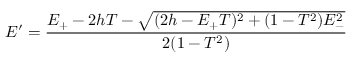<formula> <loc_0><loc_0><loc_500><loc_500>E ^ { \prime } = \frac { E _ { + } - 2 h T - \sqrt { ( 2 h - E _ { + } T ) ^ { 2 } + ( 1 - T ^ { 2 } ) E _ { - } ^ { 2 } } } { 2 ( 1 - T ^ { 2 } ) }</formula> 